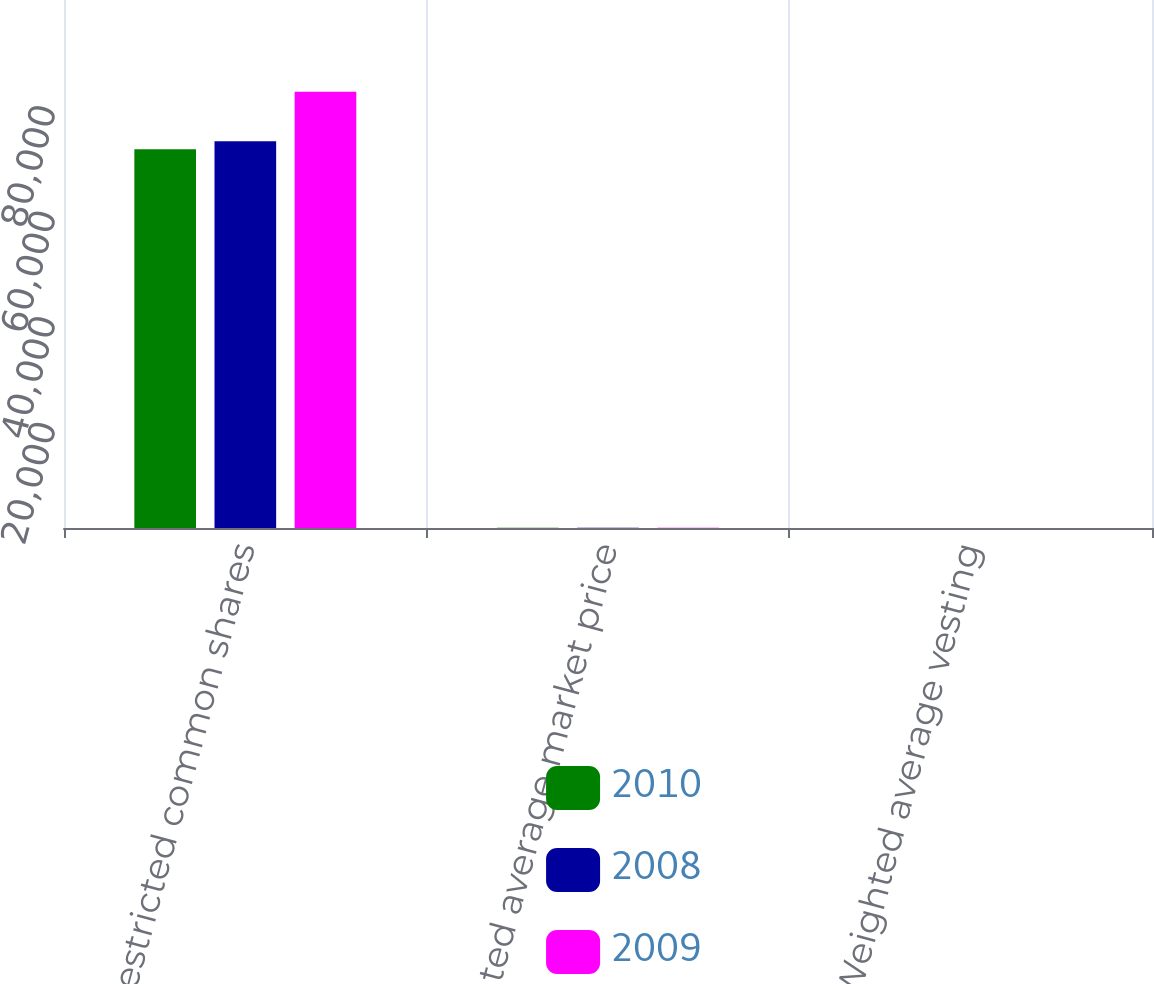Convert chart. <chart><loc_0><loc_0><loc_500><loc_500><stacked_bar_chart><ecel><fcel>Restricted common shares<fcel>Weighted average market price<fcel>Weighted average vesting<nl><fcel>2010<fcel>71752<fcel>38.43<fcel>4.74<nl><fcel>2008<fcel>73255<fcel>43.68<fcel>4.42<nl><fcel>2009<fcel>82607<fcel>68.98<fcel>5.03<nl></chart> 